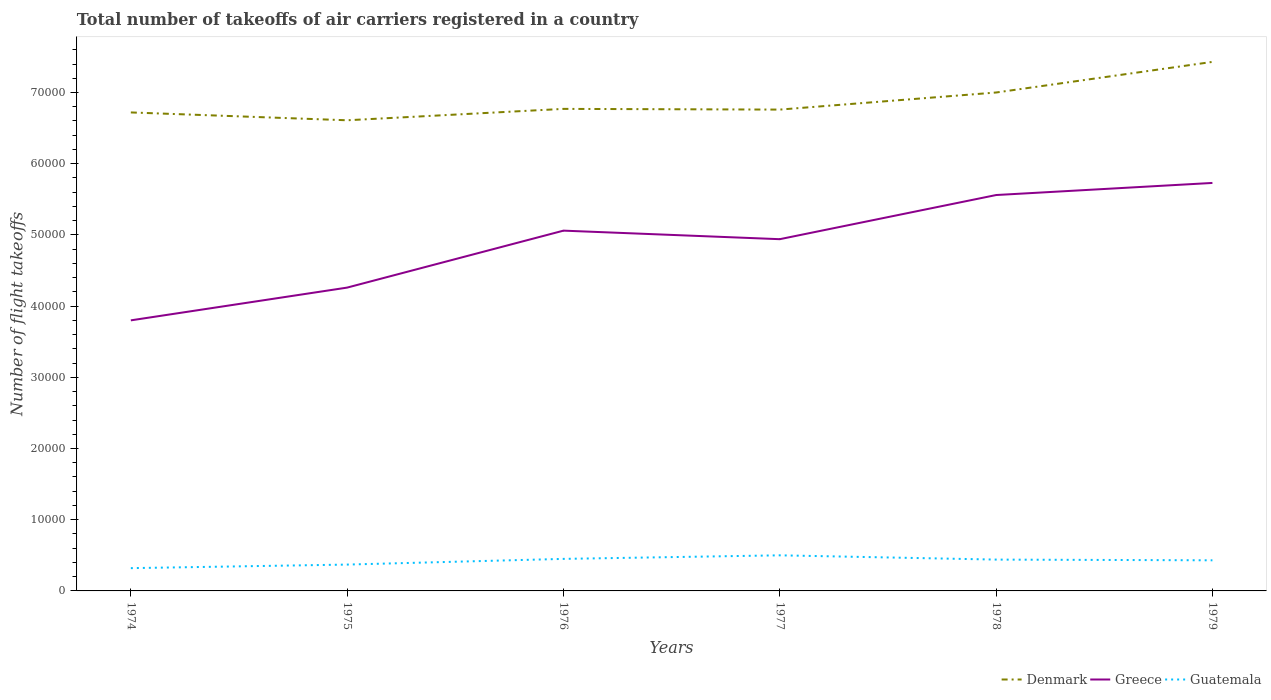Does the line corresponding to Guatemala intersect with the line corresponding to Greece?
Your answer should be very brief. No. Across all years, what is the maximum total number of flight takeoffs in Denmark?
Provide a short and direct response. 6.61e+04. In which year was the total number of flight takeoffs in Denmark maximum?
Offer a terse response. 1975. What is the total total number of flight takeoffs in Greece in the graph?
Your response must be concise. -1.26e+04. What is the difference between the highest and the second highest total number of flight takeoffs in Greece?
Make the answer very short. 1.93e+04. What is the difference between the highest and the lowest total number of flight takeoffs in Denmark?
Make the answer very short. 2. Is the total number of flight takeoffs in Guatemala strictly greater than the total number of flight takeoffs in Denmark over the years?
Provide a succinct answer. Yes. How many lines are there?
Provide a succinct answer. 3. How many years are there in the graph?
Your response must be concise. 6. Does the graph contain any zero values?
Give a very brief answer. No. Does the graph contain grids?
Offer a very short reply. No. What is the title of the graph?
Keep it short and to the point. Total number of takeoffs of air carriers registered in a country. What is the label or title of the X-axis?
Your answer should be very brief. Years. What is the label or title of the Y-axis?
Ensure brevity in your answer.  Number of flight takeoffs. What is the Number of flight takeoffs of Denmark in 1974?
Give a very brief answer. 6.72e+04. What is the Number of flight takeoffs in Greece in 1974?
Offer a very short reply. 3.80e+04. What is the Number of flight takeoffs in Guatemala in 1974?
Ensure brevity in your answer.  3200. What is the Number of flight takeoffs in Denmark in 1975?
Offer a terse response. 6.61e+04. What is the Number of flight takeoffs of Greece in 1975?
Your response must be concise. 4.26e+04. What is the Number of flight takeoffs of Guatemala in 1975?
Offer a terse response. 3700. What is the Number of flight takeoffs of Denmark in 1976?
Your answer should be very brief. 6.77e+04. What is the Number of flight takeoffs in Greece in 1976?
Your response must be concise. 5.06e+04. What is the Number of flight takeoffs of Guatemala in 1976?
Offer a terse response. 4500. What is the Number of flight takeoffs in Denmark in 1977?
Ensure brevity in your answer.  6.76e+04. What is the Number of flight takeoffs in Greece in 1977?
Give a very brief answer. 4.94e+04. What is the Number of flight takeoffs in Greece in 1978?
Offer a terse response. 5.56e+04. What is the Number of flight takeoffs in Guatemala in 1978?
Ensure brevity in your answer.  4400. What is the Number of flight takeoffs of Denmark in 1979?
Give a very brief answer. 7.43e+04. What is the Number of flight takeoffs of Greece in 1979?
Make the answer very short. 5.73e+04. What is the Number of flight takeoffs of Guatemala in 1979?
Your answer should be compact. 4300. Across all years, what is the maximum Number of flight takeoffs in Denmark?
Your answer should be compact. 7.43e+04. Across all years, what is the maximum Number of flight takeoffs of Greece?
Your response must be concise. 5.73e+04. Across all years, what is the maximum Number of flight takeoffs in Guatemala?
Make the answer very short. 5000. Across all years, what is the minimum Number of flight takeoffs in Denmark?
Your answer should be compact. 6.61e+04. Across all years, what is the minimum Number of flight takeoffs in Greece?
Provide a succinct answer. 3.80e+04. Across all years, what is the minimum Number of flight takeoffs of Guatemala?
Offer a very short reply. 3200. What is the total Number of flight takeoffs of Denmark in the graph?
Give a very brief answer. 4.13e+05. What is the total Number of flight takeoffs of Greece in the graph?
Provide a succinct answer. 2.94e+05. What is the total Number of flight takeoffs in Guatemala in the graph?
Your answer should be very brief. 2.51e+04. What is the difference between the Number of flight takeoffs in Denmark in 1974 and that in 1975?
Ensure brevity in your answer.  1100. What is the difference between the Number of flight takeoffs of Greece in 1974 and that in 1975?
Your answer should be very brief. -4600. What is the difference between the Number of flight takeoffs in Guatemala in 1974 and that in 1975?
Give a very brief answer. -500. What is the difference between the Number of flight takeoffs in Denmark in 1974 and that in 1976?
Offer a terse response. -500. What is the difference between the Number of flight takeoffs of Greece in 1974 and that in 1976?
Your answer should be compact. -1.26e+04. What is the difference between the Number of flight takeoffs of Guatemala in 1974 and that in 1976?
Provide a succinct answer. -1300. What is the difference between the Number of flight takeoffs of Denmark in 1974 and that in 1977?
Give a very brief answer. -400. What is the difference between the Number of flight takeoffs in Greece in 1974 and that in 1977?
Keep it short and to the point. -1.14e+04. What is the difference between the Number of flight takeoffs in Guatemala in 1974 and that in 1977?
Offer a terse response. -1800. What is the difference between the Number of flight takeoffs of Denmark in 1974 and that in 1978?
Your answer should be compact. -2800. What is the difference between the Number of flight takeoffs of Greece in 1974 and that in 1978?
Provide a succinct answer. -1.76e+04. What is the difference between the Number of flight takeoffs in Guatemala in 1974 and that in 1978?
Provide a short and direct response. -1200. What is the difference between the Number of flight takeoffs in Denmark in 1974 and that in 1979?
Your response must be concise. -7100. What is the difference between the Number of flight takeoffs in Greece in 1974 and that in 1979?
Offer a very short reply. -1.93e+04. What is the difference between the Number of flight takeoffs of Guatemala in 1974 and that in 1979?
Your answer should be compact. -1100. What is the difference between the Number of flight takeoffs in Denmark in 1975 and that in 1976?
Make the answer very short. -1600. What is the difference between the Number of flight takeoffs of Greece in 1975 and that in 1976?
Provide a succinct answer. -8000. What is the difference between the Number of flight takeoffs in Guatemala in 1975 and that in 1976?
Provide a short and direct response. -800. What is the difference between the Number of flight takeoffs in Denmark in 1975 and that in 1977?
Offer a very short reply. -1500. What is the difference between the Number of flight takeoffs of Greece in 1975 and that in 1977?
Your answer should be compact. -6800. What is the difference between the Number of flight takeoffs in Guatemala in 1975 and that in 1977?
Your answer should be compact. -1300. What is the difference between the Number of flight takeoffs of Denmark in 1975 and that in 1978?
Ensure brevity in your answer.  -3900. What is the difference between the Number of flight takeoffs of Greece in 1975 and that in 1978?
Offer a very short reply. -1.30e+04. What is the difference between the Number of flight takeoffs in Guatemala in 1975 and that in 1978?
Ensure brevity in your answer.  -700. What is the difference between the Number of flight takeoffs of Denmark in 1975 and that in 1979?
Give a very brief answer. -8200. What is the difference between the Number of flight takeoffs in Greece in 1975 and that in 1979?
Offer a terse response. -1.47e+04. What is the difference between the Number of flight takeoffs in Guatemala in 1975 and that in 1979?
Ensure brevity in your answer.  -600. What is the difference between the Number of flight takeoffs of Denmark in 1976 and that in 1977?
Keep it short and to the point. 100. What is the difference between the Number of flight takeoffs of Greece in 1976 and that in 1977?
Keep it short and to the point. 1200. What is the difference between the Number of flight takeoffs of Guatemala in 1976 and that in 1977?
Your response must be concise. -500. What is the difference between the Number of flight takeoffs in Denmark in 1976 and that in 1978?
Make the answer very short. -2300. What is the difference between the Number of flight takeoffs in Greece in 1976 and that in 1978?
Your answer should be very brief. -5000. What is the difference between the Number of flight takeoffs of Guatemala in 1976 and that in 1978?
Your response must be concise. 100. What is the difference between the Number of flight takeoffs in Denmark in 1976 and that in 1979?
Your answer should be very brief. -6600. What is the difference between the Number of flight takeoffs in Greece in 1976 and that in 1979?
Provide a succinct answer. -6700. What is the difference between the Number of flight takeoffs in Denmark in 1977 and that in 1978?
Your response must be concise. -2400. What is the difference between the Number of flight takeoffs of Greece in 1977 and that in 1978?
Offer a terse response. -6200. What is the difference between the Number of flight takeoffs in Guatemala in 1977 and that in 1978?
Your answer should be very brief. 600. What is the difference between the Number of flight takeoffs of Denmark in 1977 and that in 1979?
Make the answer very short. -6700. What is the difference between the Number of flight takeoffs in Greece in 1977 and that in 1979?
Offer a very short reply. -7900. What is the difference between the Number of flight takeoffs of Guatemala in 1977 and that in 1979?
Your answer should be very brief. 700. What is the difference between the Number of flight takeoffs in Denmark in 1978 and that in 1979?
Provide a short and direct response. -4300. What is the difference between the Number of flight takeoffs in Greece in 1978 and that in 1979?
Ensure brevity in your answer.  -1700. What is the difference between the Number of flight takeoffs of Guatemala in 1978 and that in 1979?
Your response must be concise. 100. What is the difference between the Number of flight takeoffs in Denmark in 1974 and the Number of flight takeoffs in Greece in 1975?
Give a very brief answer. 2.46e+04. What is the difference between the Number of flight takeoffs in Denmark in 1974 and the Number of flight takeoffs in Guatemala in 1975?
Your answer should be compact. 6.35e+04. What is the difference between the Number of flight takeoffs in Greece in 1974 and the Number of flight takeoffs in Guatemala in 1975?
Your answer should be very brief. 3.43e+04. What is the difference between the Number of flight takeoffs of Denmark in 1974 and the Number of flight takeoffs of Greece in 1976?
Your answer should be compact. 1.66e+04. What is the difference between the Number of flight takeoffs of Denmark in 1974 and the Number of flight takeoffs of Guatemala in 1976?
Your answer should be very brief. 6.27e+04. What is the difference between the Number of flight takeoffs of Greece in 1974 and the Number of flight takeoffs of Guatemala in 1976?
Make the answer very short. 3.35e+04. What is the difference between the Number of flight takeoffs in Denmark in 1974 and the Number of flight takeoffs in Greece in 1977?
Give a very brief answer. 1.78e+04. What is the difference between the Number of flight takeoffs of Denmark in 1974 and the Number of flight takeoffs of Guatemala in 1977?
Your response must be concise. 6.22e+04. What is the difference between the Number of flight takeoffs in Greece in 1974 and the Number of flight takeoffs in Guatemala in 1977?
Your response must be concise. 3.30e+04. What is the difference between the Number of flight takeoffs in Denmark in 1974 and the Number of flight takeoffs in Greece in 1978?
Make the answer very short. 1.16e+04. What is the difference between the Number of flight takeoffs of Denmark in 1974 and the Number of flight takeoffs of Guatemala in 1978?
Provide a short and direct response. 6.28e+04. What is the difference between the Number of flight takeoffs of Greece in 1974 and the Number of flight takeoffs of Guatemala in 1978?
Your answer should be very brief. 3.36e+04. What is the difference between the Number of flight takeoffs in Denmark in 1974 and the Number of flight takeoffs in Greece in 1979?
Keep it short and to the point. 9900. What is the difference between the Number of flight takeoffs in Denmark in 1974 and the Number of flight takeoffs in Guatemala in 1979?
Give a very brief answer. 6.29e+04. What is the difference between the Number of flight takeoffs in Greece in 1974 and the Number of flight takeoffs in Guatemala in 1979?
Your answer should be compact. 3.37e+04. What is the difference between the Number of flight takeoffs in Denmark in 1975 and the Number of flight takeoffs in Greece in 1976?
Your response must be concise. 1.55e+04. What is the difference between the Number of flight takeoffs of Denmark in 1975 and the Number of flight takeoffs of Guatemala in 1976?
Your answer should be very brief. 6.16e+04. What is the difference between the Number of flight takeoffs in Greece in 1975 and the Number of flight takeoffs in Guatemala in 1976?
Offer a terse response. 3.81e+04. What is the difference between the Number of flight takeoffs of Denmark in 1975 and the Number of flight takeoffs of Greece in 1977?
Offer a very short reply. 1.67e+04. What is the difference between the Number of flight takeoffs of Denmark in 1975 and the Number of flight takeoffs of Guatemala in 1977?
Ensure brevity in your answer.  6.11e+04. What is the difference between the Number of flight takeoffs of Greece in 1975 and the Number of flight takeoffs of Guatemala in 1977?
Provide a short and direct response. 3.76e+04. What is the difference between the Number of flight takeoffs of Denmark in 1975 and the Number of flight takeoffs of Greece in 1978?
Your response must be concise. 1.05e+04. What is the difference between the Number of flight takeoffs of Denmark in 1975 and the Number of flight takeoffs of Guatemala in 1978?
Ensure brevity in your answer.  6.17e+04. What is the difference between the Number of flight takeoffs in Greece in 1975 and the Number of flight takeoffs in Guatemala in 1978?
Give a very brief answer. 3.82e+04. What is the difference between the Number of flight takeoffs in Denmark in 1975 and the Number of flight takeoffs in Greece in 1979?
Offer a very short reply. 8800. What is the difference between the Number of flight takeoffs of Denmark in 1975 and the Number of flight takeoffs of Guatemala in 1979?
Offer a very short reply. 6.18e+04. What is the difference between the Number of flight takeoffs in Greece in 1975 and the Number of flight takeoffs in Guatemala in 1979?
Make the answer very short. 3.83e+04. What is the difference between the Number of flight takeoffs in Denmark in 1976 and the Number of flight takeoffs in Greece in 1977?
Your answer should be very brief. 1.83e+04. What is the difference between the Number of flight takeoffs in Denmark in 1976 and the Number of flight takeoffs in Guatemala in 1977?
Your answer should be very brief. 6.27e+04. What is the difference between the Number of flight takeoffs of Greece in 1976 and the Number of flight takeoffs of Guatemala in 1977?
Your answer should be very brief. 4.56e+04. What is the difference between the Number of flight takeoffs of Denmark in 1976 and the Number of flight takeoffs of Greece in 1978?
Offer a very short reply. 1.21e+04. What is the difference between the Number of flight takeoffs of Denmark in 1976 and the Number of flight takeoffs of Guatemala in 1978?
Your answer should be compact. 6.33e+04. What is the difference between the Number of flight takeoffs in Greece in 1976 and the Number of flight takeoffs in Guatemala in 1978?
Your response must be concise. 4.62e+04. What is the difference between the Number of flight takeoffs of Denmark in 1976 and the Number of flight takeoffs of Greece in 1979?
Keep it short and to the point. 1.04e+04. What is the difference between the Number of flight takeoffs of Denmark in 1976 and the Number of flight takeoffs of Guatemala in 1979?
Provide a succinct answer. 6.34e+04. What is the difference between the Number of flight takeoffs in Greece in 1976 and the Number of flight takeoffs in Guatemala in 1979?
Give a very brief answer. 4.63e+04. What is the difference between the Number of flight takeoffs in Denmark in 1977 and the Number of flight takeoffs in Greece in 1978?
Your answer should be very brief. 1.20e+04. What is the difference between the Number of flight takeoffs of Denmark in 1977 and the Number of flight takeoffs of Guatemala in 1978?
Your answer should be compact. 6.32e+04. What is the difference between the Number of flight takeoffs in Greece in 1977 and the Number of flight takeoffs in Guatemala in 1978?
Offer a terse response. 4.50e+04. What is the difference between the Number of flight takeoffs in Denmark in 1977 and the Number of flight takeoffs in Greece in 1979?
Give a very brief answer. 1.03e+04. What is the difference between the Number of flight takeoffs in Denmark in 1977 and the Number of flight takeoffs in Guatemala in 1979?
Offer a very short reply. 6.33e+04. What is the difference between the Number of flight takeoffs of Greece in 1977 and the Number of flight takeoffs of Guatemala in 1979?
Your answer should be very brief. 4.51e+04. What is the difference between the Number of flight takeoffs in Denmark in 1978 and the Number of flight takeoffs in Greece in 1979?
Give a very brief answer. 1.27e+04. What is the difference between the Number of flight takeoffs of Denmark in 1978 and the Number of flight takeoffs of Guatemala in 1979?
Provide a short and direct response. 6.57e+04. What is the difference between the Number of flight takeoffs in Greece in 1978 and the Number of flight takeoffs in Guatemala in 1979?
Keep it short and to the point. 5.13e+04. What is the average Number of flight takeoffs of Denmark per year?
Offer a terse response. 6.88e+04. What is the average Number of flight takeoffs of Greece per year?
Provide a succinct answer. 4.89e+04. What is the average Number of flight takeoffs of Guatemala per year?
Offer a very short reply. 4183.33. In the year 1974, what is the difference between the Number of flight takeoffs of Denmark and Number of flight takeoffs of Greece?
Offer a terse response. 2.92e+04. In the year 1974, what is the difference between the Number of flight takeoffs in Denmark and Number of flight takeoffs in Guatemala?
Ensure brevity in your answer.  6.40e+04. In the year 1974, what is the difference between the Number of flight takeoffs in Greece and Number of flight takeoffs in Guatemala?
Provide a short and direct response. 3.48e+04. In the year 1975, what is the difference between the Number of flight takeoffs in Denmark and Number of flight takeoffs in Greece?
Provide a succinct answer. 2.35e+04. In the year 1975, what is the difference between the Number of flight takeoffs of Denmark and Number of flight takeoffs of Guatemala?
Offer a terse response. 6.24e+04. In the year 1975, what is the difference between the Number of flight takeoffs in Greece and Number of flight takeoffs in Guatemala?
Offer a very short reply. 3.89e+04. In the year 1976, what is the difference between the Number of flight takeoffs of Denmark and Number of flight takeoffs of Greece?
Keep it short and to the point. 1.71e+04. In the year 1976, what is the difference between the Number of flight takeoffs in Denmark and Number of flight takeoffs in Guatemala?
Your answer should be very brief. 6.32e+04. In the year 1976, what is the difference between the Number of flight takeoffs in Greece and Number of flight takeoffs in Guatemala?
Provide a short and direct response. 4.61e+04. In the year 1977, what is the difference between the Number of flight takeoffs in Denmark and Number of flight takeoffs in Greece?
Provide a short and direct response. 1.82e+04. In the year 1977, what is the difference between the Number of flight takeoffs in Denmark and Number of flight takeoffs in Guatemala?
Your response must be concise. 6.26e+04. In the year 1977, what is the difference between the Number of flight takeoffs of Greece and Number of flight takeoffs of Guatemala?
Provide a succinct answer. 4.44e+04. In the year 1978, what is the difference between the Number of flight takeoffs in Denmark and Number of flight takeoffs in Greece?
Your answer should be compact. 1.44e+04. In the year 1978, what is the difference between the Number of flight takeoffs of Denmark and Number of flight takeoffs of Guatemala?
Ensure brevity in your answer.  6.56e+04. In the year 1978, what is the difference between the Number of flight takeoffs in Greece and Number of flight takeoffs in Guatemala?
Make the answer very short. 5.12e+04. In the year 1979, what is the difference between the Number of flight takeoffs in Denmark and Number of flight takeoffs in Greece?
Make the answer very short. 1.70e+04. In the year 1979, what is the difference between the Number of flight takeoffs of Denmark and Number of flight takeoffs of Guatemala?
Your answer should be very brief. 7.00e+04. In the year 1979, what is the difference between the Number of flight takeoffs of Greece and Number of flight takeoffs of Guatemala?
Keep it short and to the point. 5.30e+04. What is the ratio of the Number of flight takeoffs in Denmark in 1974 to that in 1975?
Your answer should be compact. 1.02. What is the ratio of the Number of flight takeoffs in Greece in 1974 to that in 1975?
Provide a short and direct response. 0.89. What is the ratio of the Number of flight takeoffs of Guatemala in 1974 to that in 1975?
Your answer should be compact. 0.86. What is the ratio of the Number of flight takeoffs in Greece in 1974 to that in 1976?
Provide a succinct answer. 0.75. What is the ratio of the Number of flight takeoffs of Guatemala in 1974 to that in 1976?
Your answer should be very brief. 0.71. What is the ratio of the Number of flight takeoffs in Greece in 1974 to that in 1977?
Make the answer very short. 0.77. What is the ratio of the Number of flight takeoffs of Guatemala in 1974 to that in 1977?
Make the answer very short. 0.64. What is the ratio of the Number of flight takeoffs in Denmark in 1974 to that in 1978?
Ensure brevity in your answer.  0.96. What is the ratio of the Number of flight takeoffs of Greece in 1974 to that in 1978?
Give a very brief answer. 0.68. What is the ratio of the Number of flight takeoffs in Guatemala in 1974 to that in 1978?
Your response must be concise. 0.73. What is the ratio of the Number of flight takeoffs in Denmark in 1974 to that in 1979?
Offer a very short reply. 0.9. What is the ratio of the Number of flight takeoffs in Greece in 1974 to that in 1979?
Give a very brief answer. 0.66. What is the ratio of the Number of flight takeoffs in Guatemala in 1974 to that in 1979?
Make the answer very short. 0.74. What is the ratio of the Number of flight takeoffs of Denmark in 1975 to that in 1976?
Offer a terse response. 0.98. What is the ratio of the Number of flight takeoffs of Greece in 1975 to that in 1976?
Offer a very short reply. 0.84. What is the ratio of the Number of flight takeoffs in Guatemala in 1975 to that in 1976?
Your response must be concise. 0.82. What is the ratio of the Number of flight takeoffs of Denmark in 1975 to that in 1977?
Your answer should be very brief. 0.98. What is the ratio of the Number of flight takeoffs of Greece in 1975 to that in 1977?
Ensure brevity in your answer.  0.86. What is the ratio of the Number of flight takeoffs in Guatemala in 1975 to that in 1977?
Keep it short and to the point. 0.74. What is the ratio of the Number of flight takeoffs of Denmark in 1975 to that in 1978?
Your answer should be compact. 0.94. What is the ratio of the Number of flight takeoffs of Greece in 1975 to that in 1978?
Your answer should be compact. 0.77. What is the ratio of the Number of flight takeoffs of Guatemala in 1975 to that in 1978?
Ensure brevity in your answer.  0.84. What is the ratio of the Number of flight takeoffs in Denmark in 1975 to that in 1979?
Your response must be concise. 0.89. What is the ratio of the Number of flight takeoffs in Greece in 1975 to that in 1979?
Offer a very short reply. 0.74. What is the ratio of the Number of flight takeoffs in Guatemala in 1975 to that in 1979?
Provide a succinct answer. 0.86. What is the ratio of the Number of flight takeoffs in Denmark in 1976 to that in 1977?
Offer a very short reply. 1. What is the ratio of the Number of flight takeoffs in Greece in 1976 to that in 1977?
Ensure brevity in your answer.  1.02. What is the ratio of the Number of flight takeoffs in Guatemala in 1976 to that in 1977?
Offer a very short reply. 0.9. What is the ratio of the Number of flight takeoffs in Denmark in 1976 to that in 1978?
Your response must be concise. 0.97. What is the ratio of the Number of flight takeoffs of Greece in 1976 to that in 1978?
Make the answer very short. 0.91. What is the ratio of the Number of flight takeoffs in Guatemala in 1976 to that in 1978?
Give a very brief answer. 1.02. What is the ratio of the Number of flight takeoffs in Denmark in 1976 to that in 1979?
Keep it short and to the point. 0.91. What is the ratio of the Number of flight takeoffs in Greece in 1976 to that in 1979?
Offer a terse response. 0.88. What is the ratio of the Number of flight takeoffs in Guatemala in 1976 to that in 1979?
Ensure brevity in your answer.  1.05. What is the ratio of the Number of flight takeoffs in Denmark in 1977 to that in 1978?
Provide a short and direct response. 0.97. What is the ratio of the Number of flight takeoffs in Greece in 1977 to that in 1978?
Offer a very short reply. 0.89. What is the ratio of the Number of flight takeoffs of Guatemala in 1977 to that in 1978?
Your answer should be very brief. 1.14. What is the ratio of the Number of flight takeoffs in Denmark in 1977 to that in 1979?
Your response must be concise. 0.91. What is the ratio of the Number of flight takeoffs in Greece in 1977 to that in 1979?
Your response must be concise. 0.86. What is the ratio of the Number of flight takeoffs of Guatemala in 1977 to that in 1979?
Ensure brevity in your answer.  1.16. What is the ratio of the Number of flight takeoffs of Denmark in 1978 to that in 1979?
Provide a short and direct response. 0.94. What is the ratio of the Number of flight takeoffs of Greece in 1978 to that in 1979?
Provide a short and direct response. 0.97. What is the ratio of the Number of flight takeoffs in Guatemala in 1978 to that in 1979?
Your response must be concise. 1.02. What is the difference between the highest and the second highest Number of flight takeoffs of Denmark?
Your answer should be compact. 4300. What is the difference between the highest and the second highest Number of flight takeoffs in Greece?
Your answer should be very brief. 1700. What is the difference between the highest and the lowest Number of flight takeoffs in Denmark?
Provide a short and direct response. 8200. What is the difference between the highest and the lowest Number of flight takeoffs of Greece?
Offer a terse response. 1.93e+04. What is the difference between the highest and the lowest Number of flight takeoffs in Guatemala?
Give a very brief answer. 1800. 